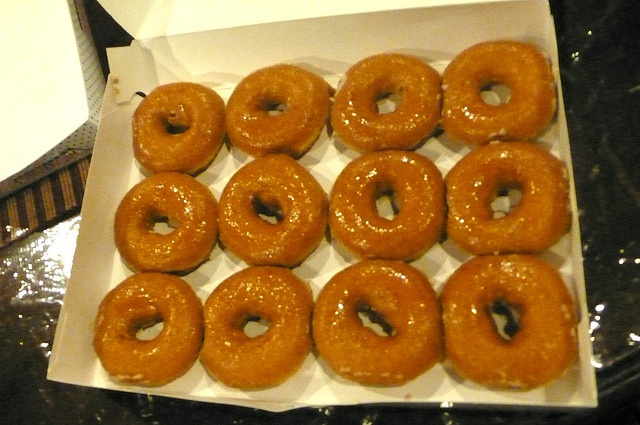Describe the objects in this image and their specific colors. I can see donut in lightyellow, red, maroon, and black tones, donut in lightyellow, red, maroon, and orange tones, donut in lightyellow, red, maroon, and orange tones, donut in lightyellow, red, orange, and maroon tones, and donut in lightyellow, red, maroon, and orange tones in this image. 